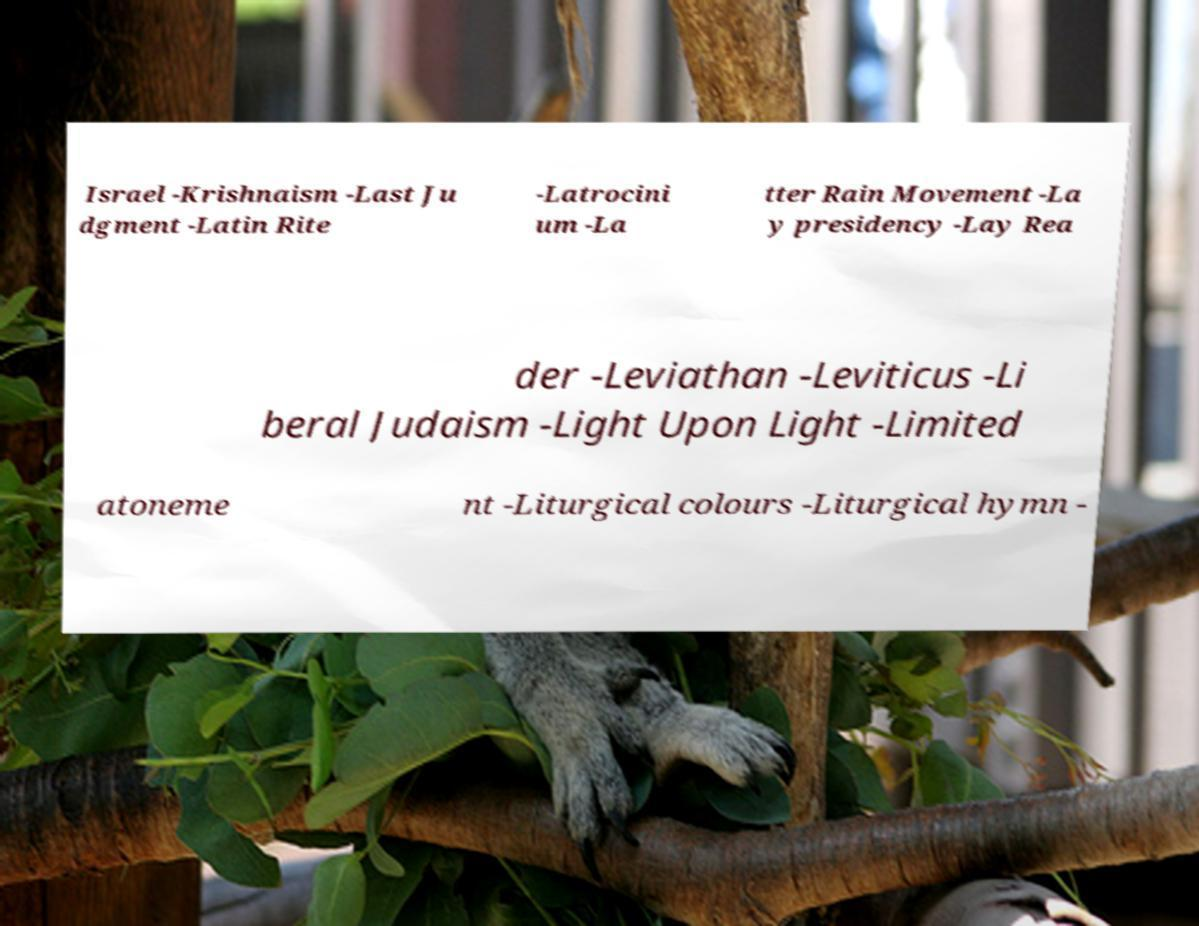Can you read and provide the text displayed in the image?This photo seems to have some interesting text. Can you extract and type it out for me? Israel -Krishnaism -Last Ju dgment -Latin Rite -Latrocini um -La tter Rain Movement -La y presidency -Lay Rea der -Leviathan -Leviticus -Li beral Judaism -Light Upon Light -Limited atoneme nt -Liturgical colours -Liturgical hymn - 